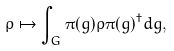Convert formula to latex. <formula><loc_0><loc_0><loc_500><loc_500>\rho \mapsto \int _ { G } \pi ( g ) \rho \pi ( g ) ^ { \dagger } d g ,</formula> 